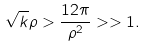<formula> <loc_0><loc_0><loc_500><loc_500>\sqrt { k } \rho > \frac { 1 2 \pi } { \rho ^ { 2 } } > > 1 .</formula> 